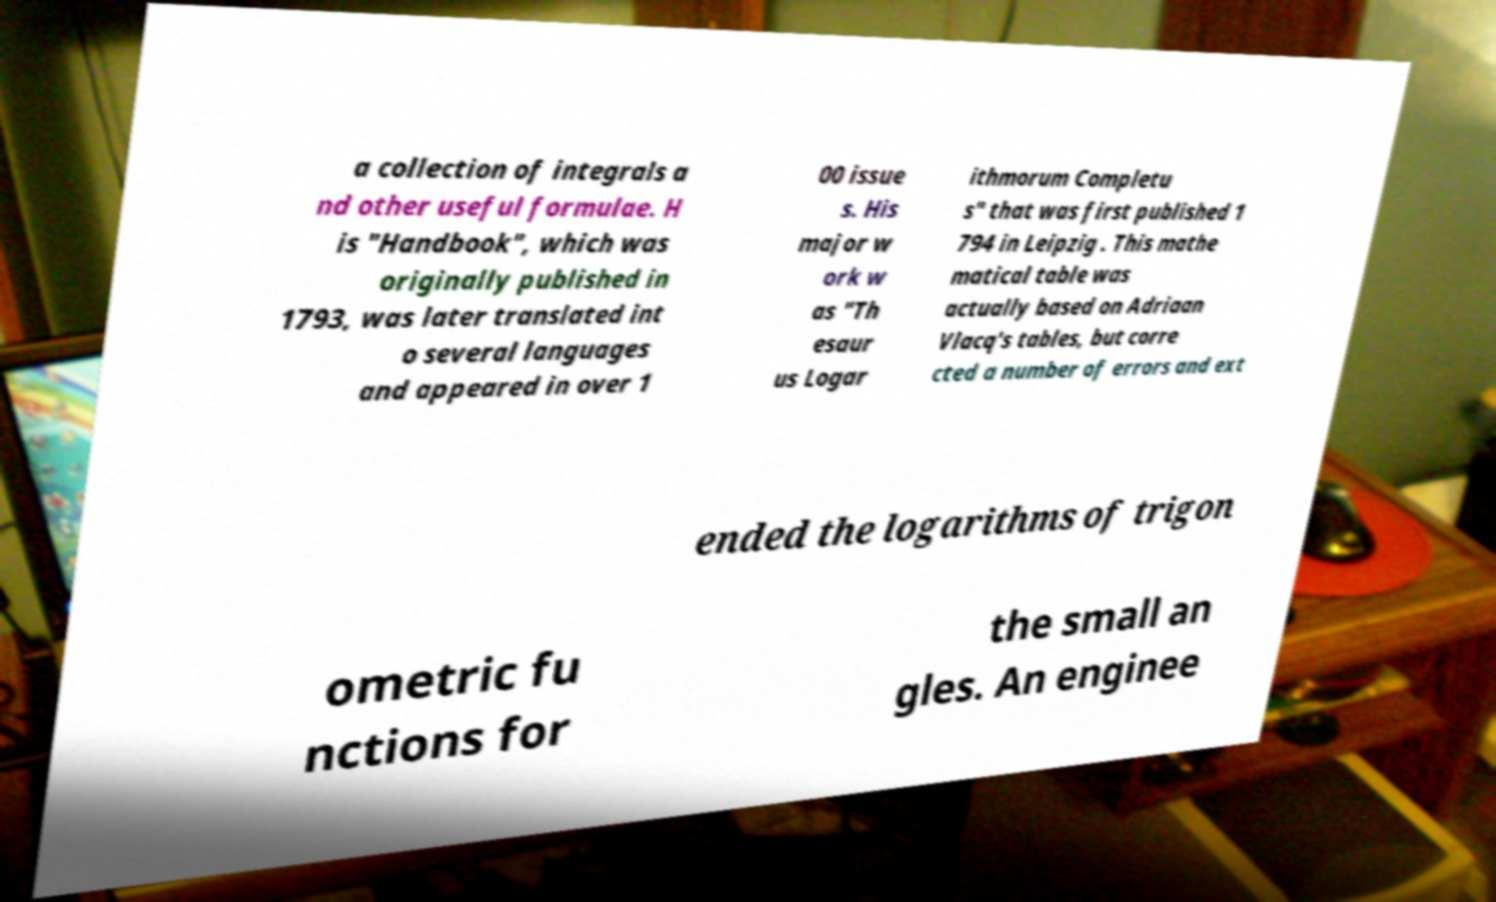Can you read and provide the text displayed in the image?This photo seems to have some interesting text. Can you extract and type it out for me? a collection of integrals a nd other useful formulae. H is "Handbook", which was originally published in 1793, was later translated int o several languages and appeared in over 1 00 issue s. His major w ork w as "Th esaur us Logar ithmorum Completu s" that was first published 1 794 in Leipzig . This mathe matical table was actually based on Adriaan Vlacq's tables, but corre cted a number of errors and ext ended the logarithms of trigon ometric fu nctions for the small an gles. An enginee 